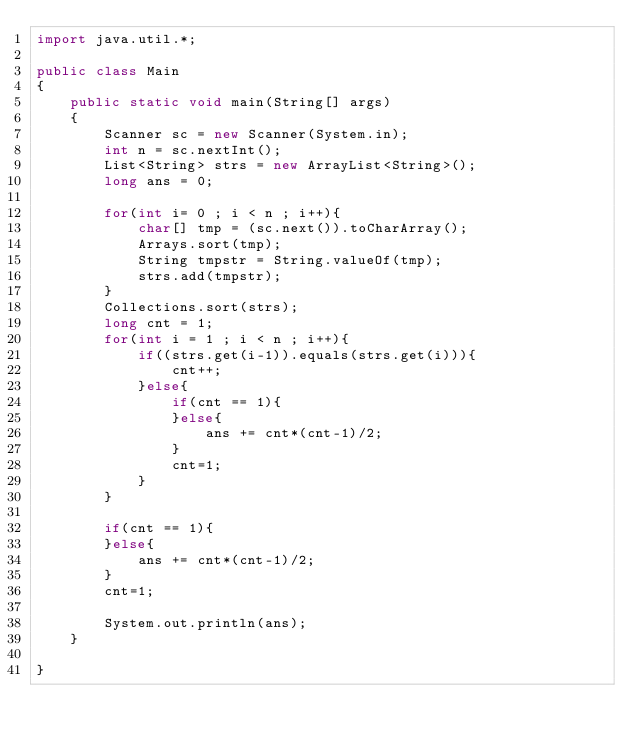Convert code to text. <code><loc_0><loc_0><loc_500><loc_500><_Java_>import java.util.*;

public class Main
{
	public static void main(String[] args)
	{
		Scanner sc = new Scanner(System.in);
		int n = sc.nextInt();
		List<String> strs = new ArrayList<String>();
		long ans = 0;

		for(int i= 0 ; i < n ; i++){
			char[] tmp = (sc.next()).toCharArray();
			Arrays.sort(tmp);
			String tmpstr = String.valueOf(tmp);
			strs.add(tmpstr);
		}
		Collections.sort(strs);
		long cnt = 1;
		for(int i = 1 ; i < n ; i++){
			if((strs.get(i-1)).equals(strs.get(i))){
				cnt++;
			}else{
				if(cnt == 1){
				}else{
					ans += cnt*(cnt-1)/2;
				}
				cnt=1;
			}
		}

		if(cnt == 1){
		}else{
			ans += cnt*(cnt-1)/2;
		}
		cnt=1;

		System.out.println(ans);
	}

}</code> 